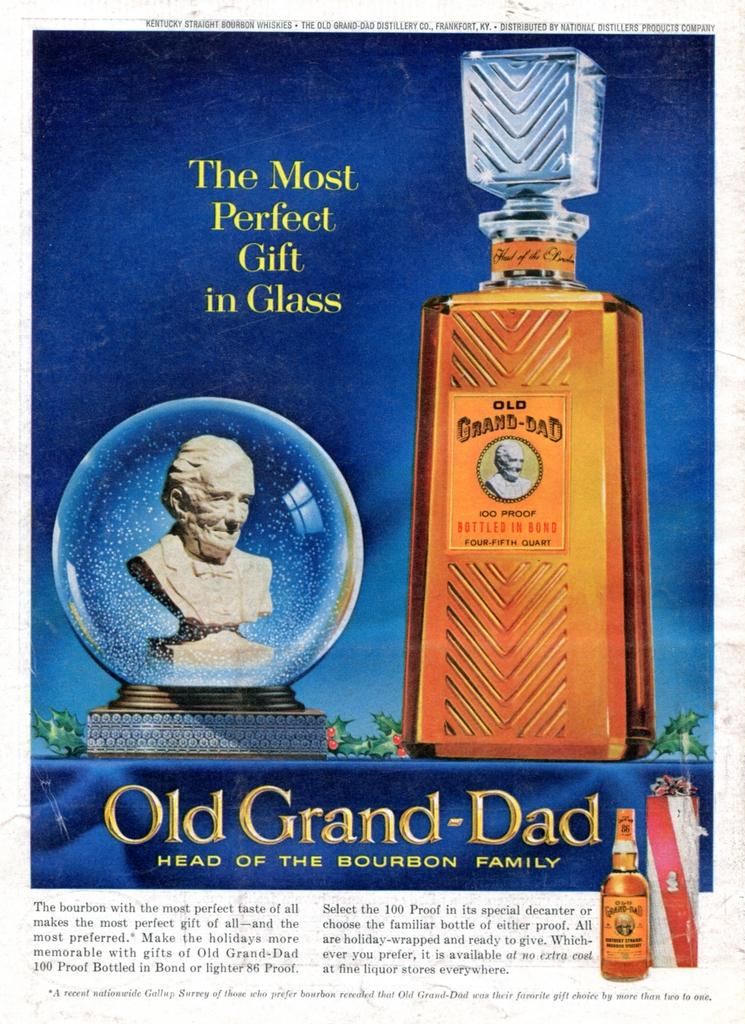<image>
Provide a brief description of the given image. An old magazine advert for Old Grand-Dad bourban showing a bust in a snowglobe next to a glass bottle. 